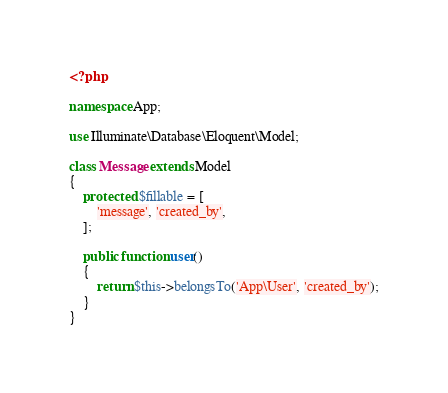Convert code to text. <code><loc_0><loc_0><loc_500><loc_500><_PHP_><?php

namespace App;

use Illuminate\Database\Eloquent\Model;

class Message extends Model
{
    protected $fillable = [
        'message', 'created_by',
    ];

    public function user()
    {
        return $this->belongsTo('App\User', 'created_by');
    }
}
</code> 